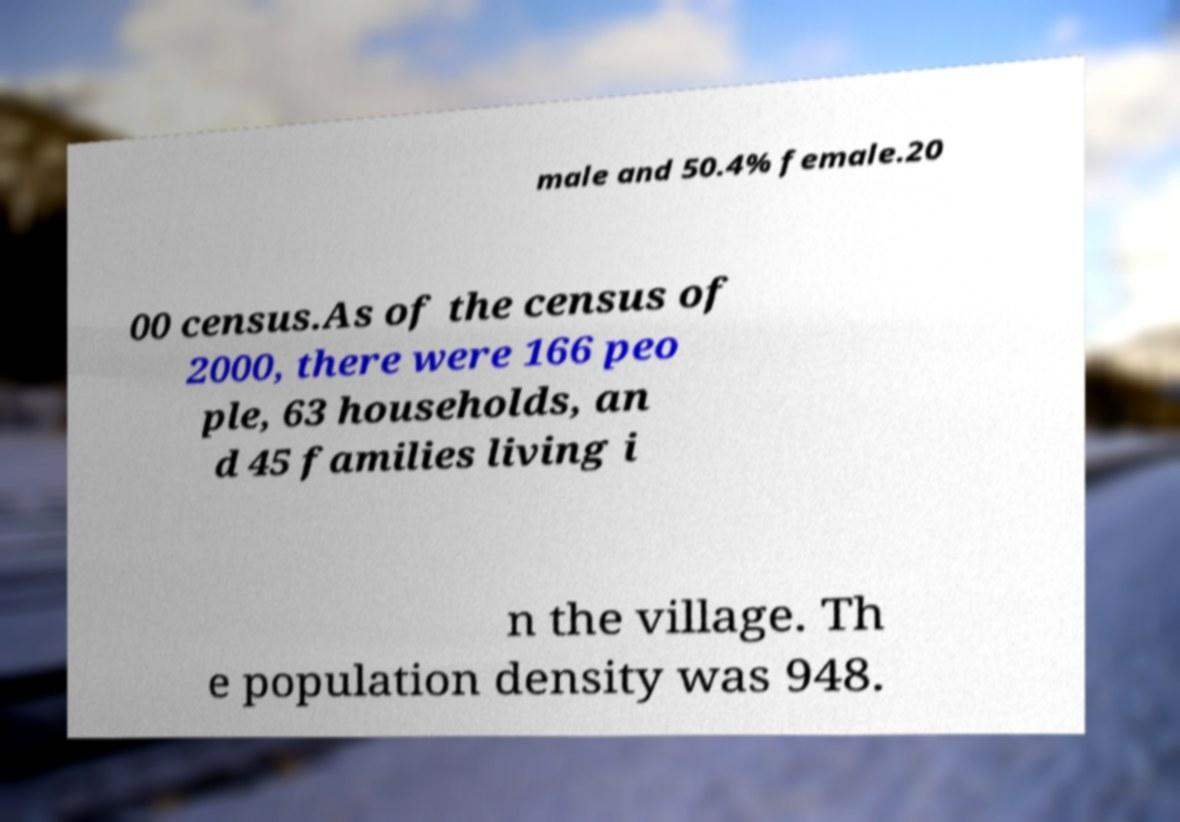What messages or text are displayed in this image? I need them in a readable, typed format. male and 50.4% female.20 00 census.As of the census of 2000, there were 166 peo ple, 63 households, an d 45 families living i n the village. Th e population density was 948. 